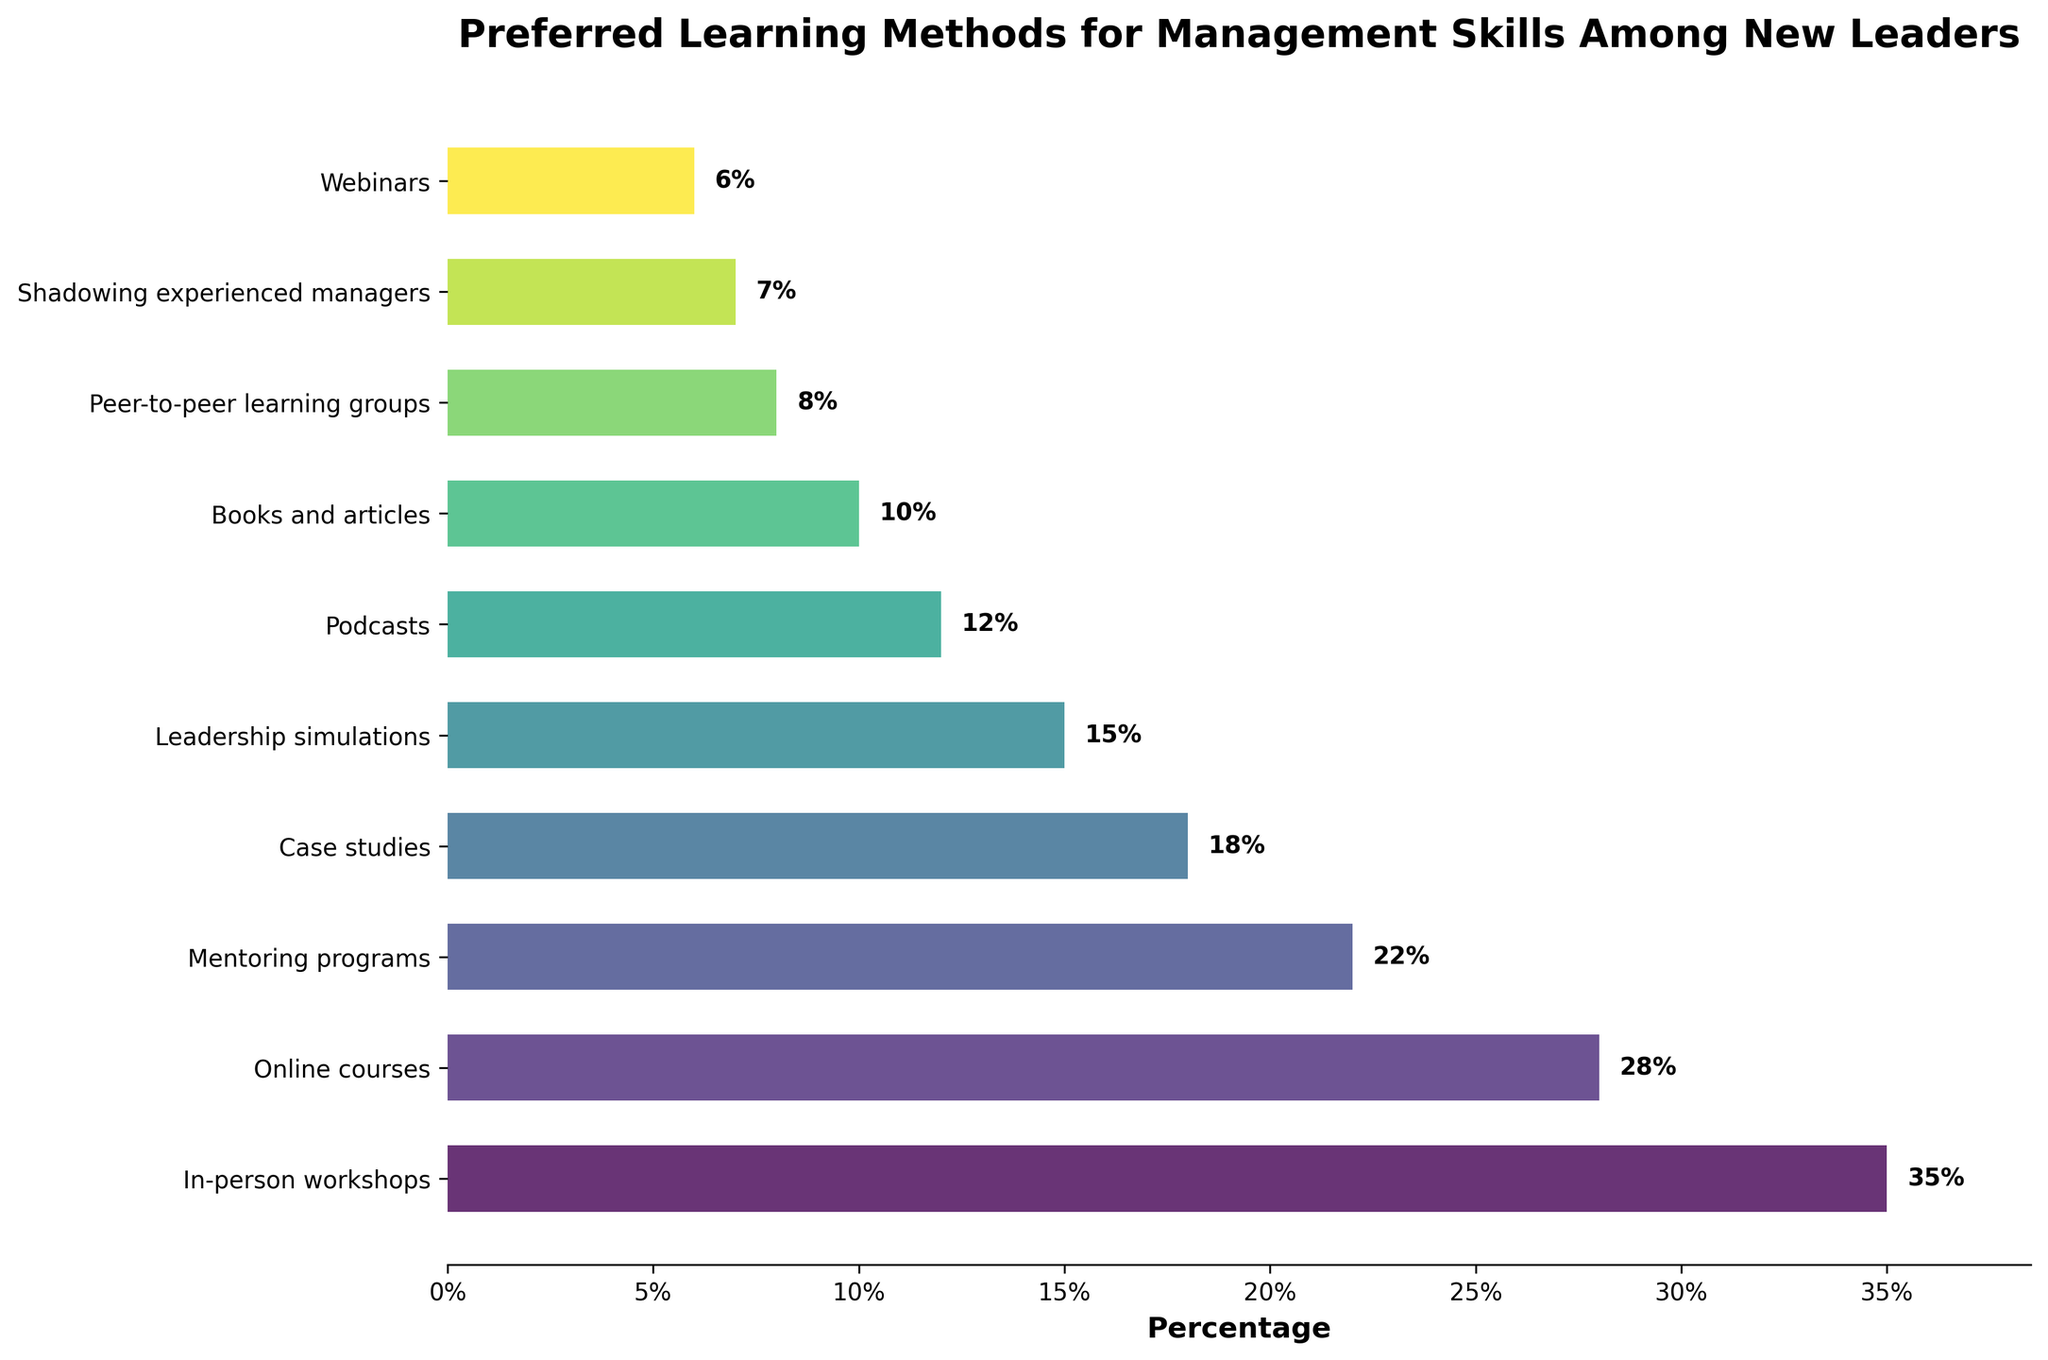Which learning method is preferred by the highest percentage of new leaders? The bar chart shows various learning methods with their corresponding percentages. The tallest bar represents the most preferred learning method. The bar for "In-person workshops" reaches the highest percentage at 35%.
Answer: In-person workshops What is the combined percentage of those preferring online courses and mentoring programs? Add the percentages of both learning methods together. Online courses have 28% and mentoring programs have 22%, so 28% + 22% = 50%.
Answer: 50% Which is more preferred by new leaders, mentoring programs or leadership simulations? Compare the lengths of the bars for mentoring programs and leadership simulations. Mentoring programs have a percentage of 22%, while leadership simulations have 15%.
Answer: Mentoring programs What is the difference in preference between podcasts and case studies? Subtract the percentage for podcasts from the percentage for case studies. Case studies have a percentage of 18% and podcasts have 12%, so 18% - 12% = 6%.
Answer: 6% How many learning methods have a preference percentage of 10% or less? Count the bars representing learning methods with percentages of 10% or less. These are: books and articles (10%), peer-to-peer learning groups (8%), shadowing experienced managers (7%), and webinars (6%). There are 4 such methods.
Answer: 4 What is the average percentage of the top three preferred learning methods? First, identify the top three methods: In-person workshops (35%), online courses (28%), and mentoring programs (22%). Calculate the average by adding these percentages and then dividing by 3. (35 + 28 + 22) / 3 = 28.33.
Answer: 28.33 Which learning method has the smallest preference percentage, and what is it? The shortest bar represents the learning method with the smallest percentage. The bar for webinars is the shortest with a percentage of 6%.
Answer: Webinars, 6% Are case studies more preferred than books and articles? Compare the bars for case studies and books and articles. Case studies have a percentage of 18%, while books and articles have 10%.
Answer: Yes 